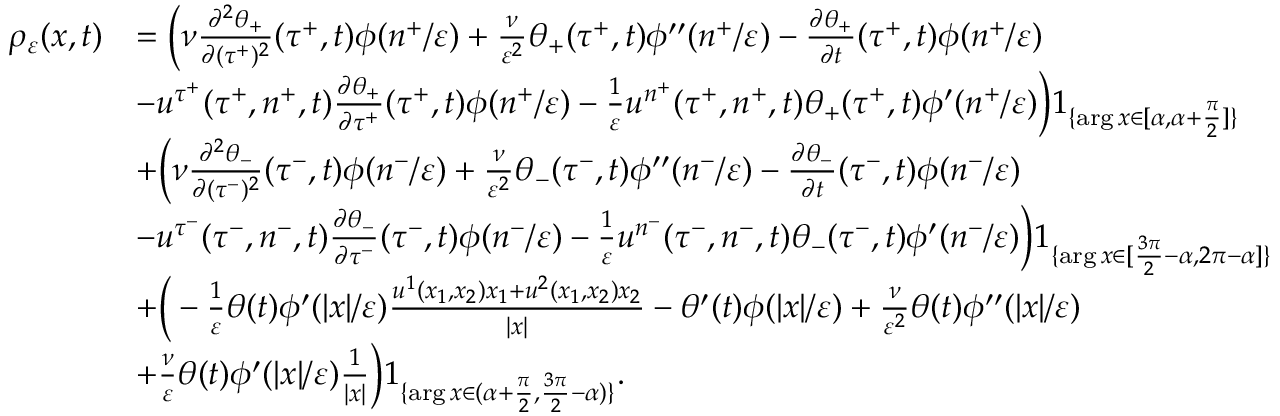Convert formula to latex. <formula><loc_0><loc_0><loc_500><loc_500>\begin{array} { r l } { \rho _ { \varepsilon } ( x , t ) } & { = \left ( \nu \frac { \partial ^ { 2 } \theta _ { + } } { \partial ( \tau ^ { + } ) ^ { 2 } } ( \tau ^ { + } , t ) \phi ( n ^ { + } / \varepsilon ) + \frac { \nu } { \varepsilon ^ { 2 } } \theta _ { + } ( \tau ^ { + } , t ) \phi ^ { \prime \prime } ( n ^ { + } / \varepsilon ) - \frac { \partial \theta _ { + } } { \partial t } ( \tau ^ { + } , t ) \phi ( n ^ { + } / \varepsilon ) } \\ & { - u ^ { \tau ^ { + } } ( \tau ^ { + } , n ^ { + } , t ) \frac { \partial \theta _ { + } } { \partial \tau ^ { + } } ( \tau ^ { + } , t ) \phi ( n ^ { + } / \varepsilon ) - \frac { 1 } { \varepsilon } u ^ { n ^ { + } } ( \tau ^ { + } , n ^ { + } , t ) \theta _ { + } ( \tau ^ { + } , t ) \phi ^ { \prime } ( n ^ { + } / \varepsilon ) \right ) 1 _ { \{ \arg x \in [ \alpha , \alpha + \frac { \pi } { 2 } ] \} } } \\ & { + \left ( \nu \frac { \partial ^ { 2 } \theta _ { - } } { \partial ( \tau ^ { - } ) ^ { 2 } } ( \tau ^ { - } , t ) \phi ( n ^ { - } / \varepsilon ) + \frac { \nu } { \varepsilon ^ { 2 } } \theta _ { - } ( \tau ^ { - } , t ) \phi ^ { \prime \prime } ( n ^ { - } / \varepsilon ) - \frac { \partial \theta _ { - } } { \partial t } ( \tau ^ { - } , t ) \phi ( n ^ { - } / \varepsilon ) } \\ & { - u ^ { \tau ^ { - } } ( \tau ^ { - } , n ^ { - } , t ) \frac { \partial \theta _ { - } } { \partial \tau ^ { - } } ( \tau ^ { - } , t ) \phi ( n ^ { - } / \varepsilon ) - \frac { 1 } { \varepsilon } u ^ { n ^ { - } } ( \tau ^ { - } , n ^ { - } , t ) \theta _ { - } ( \tau ^ { - } , t ) \phi ^ { \prime } ( n ^ { - } / \varepsilon ) \right ) 1 _ { \{ \arg x \in [ \frac { 3 \pi } { 2 } - \alpha , 2 \pi - \alpha ] \} } } \\ & { + \left ( - \frac { 1 } { \varepsilon } \theta ( t ) \phi ^ { \prime } ( | x | / \varepsilon ) \frac { u ^ { 1 } ( x _ { 1 } , x _ { 2 } ) x _ { 1 } + u ^ { 2 } ( x _ { 1 } , x _ { 2 } ) x _ { 2 } } { | x | } - \theta ^ { \prime } ( t ) \phi ( | x | / \varepsilon ) + \frac { \nu } { \varepsilon ^ { 2 } } \theta ( t ) \phi ^ { \prime \prime } ( | x | / \varepsilon ) } \\ & { + \frac { \nu } { \varepsilon } \theta ( t ) \phi ^ { \prime } ( | x | / \varepsilon ) \frac { 1 } { | x | } \right ) 1 _ { \{ \arg x \in ( \alpha + \frac { \pi } { 2 } , \frac { 3 \pi } { 2 } - \alpha ) \} } . } \end{array}</formula> 